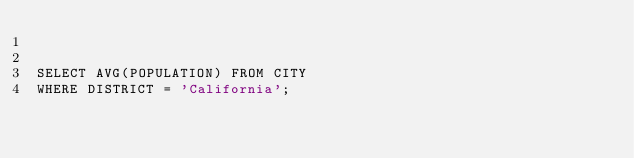<code> <loc_0><loc_0><loc_500><loc_500><_SQL_>

SELECT AVG(POPULATION) FROM CITY
WHERE DISTRICT = 'California';
</code> 